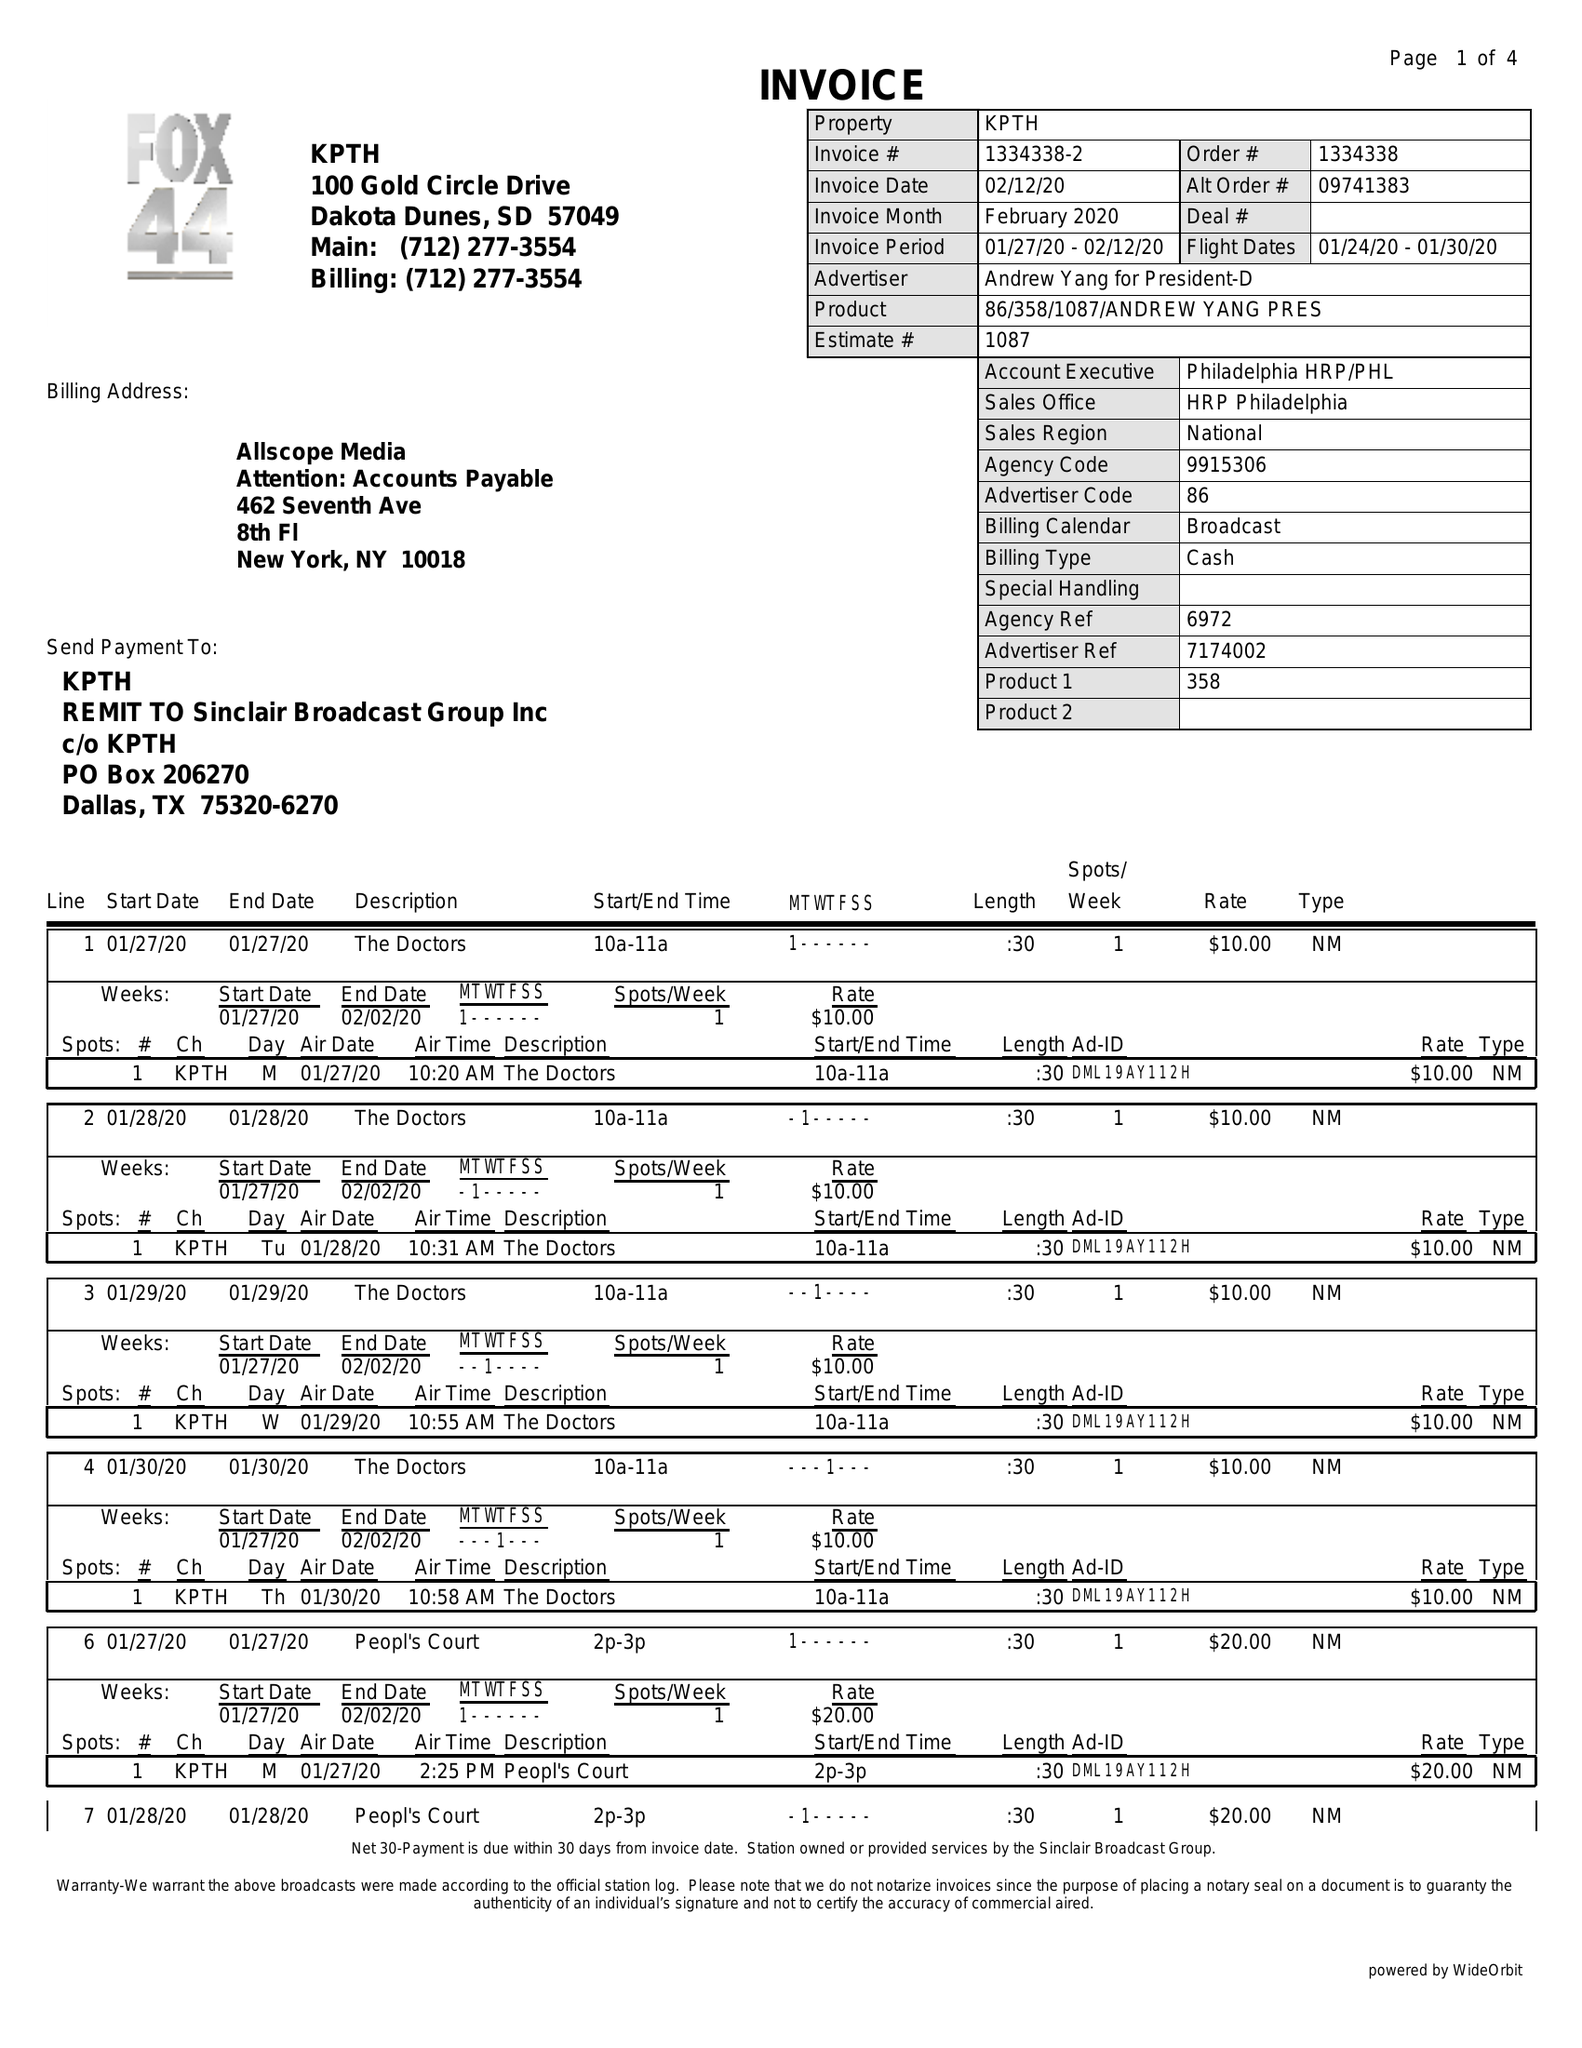What is the value for the flight_from?
Answer the question using a single word or phrase. 01/24/20 